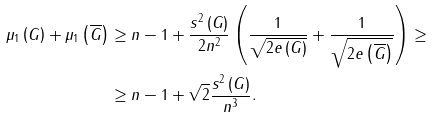Convert formula to latex. <formula><loc_0><loc_0><loc_500><loc_500>\mu _ { 1 } \left ( G \right ) + \mu _ { 1 } \left ( \overline { G } \right ) & \geq n - 1 + \frac { s ^ { 2 } \left ( G \right ) } { 2 n ^ { 2 } } \left ( \frac { 1 } { \sqrt { 2 e \left ( G \right ) } } + \frac { 1 } { \sqrt { 2 e \left ( \overline { G } \right ) } } \right ) \geq \\ & \geq n - 1 + \sqrt { 2 } \frac { s ^ { 2 } \left ( G \right ) } { n ^ { 3 } } .</formula> 